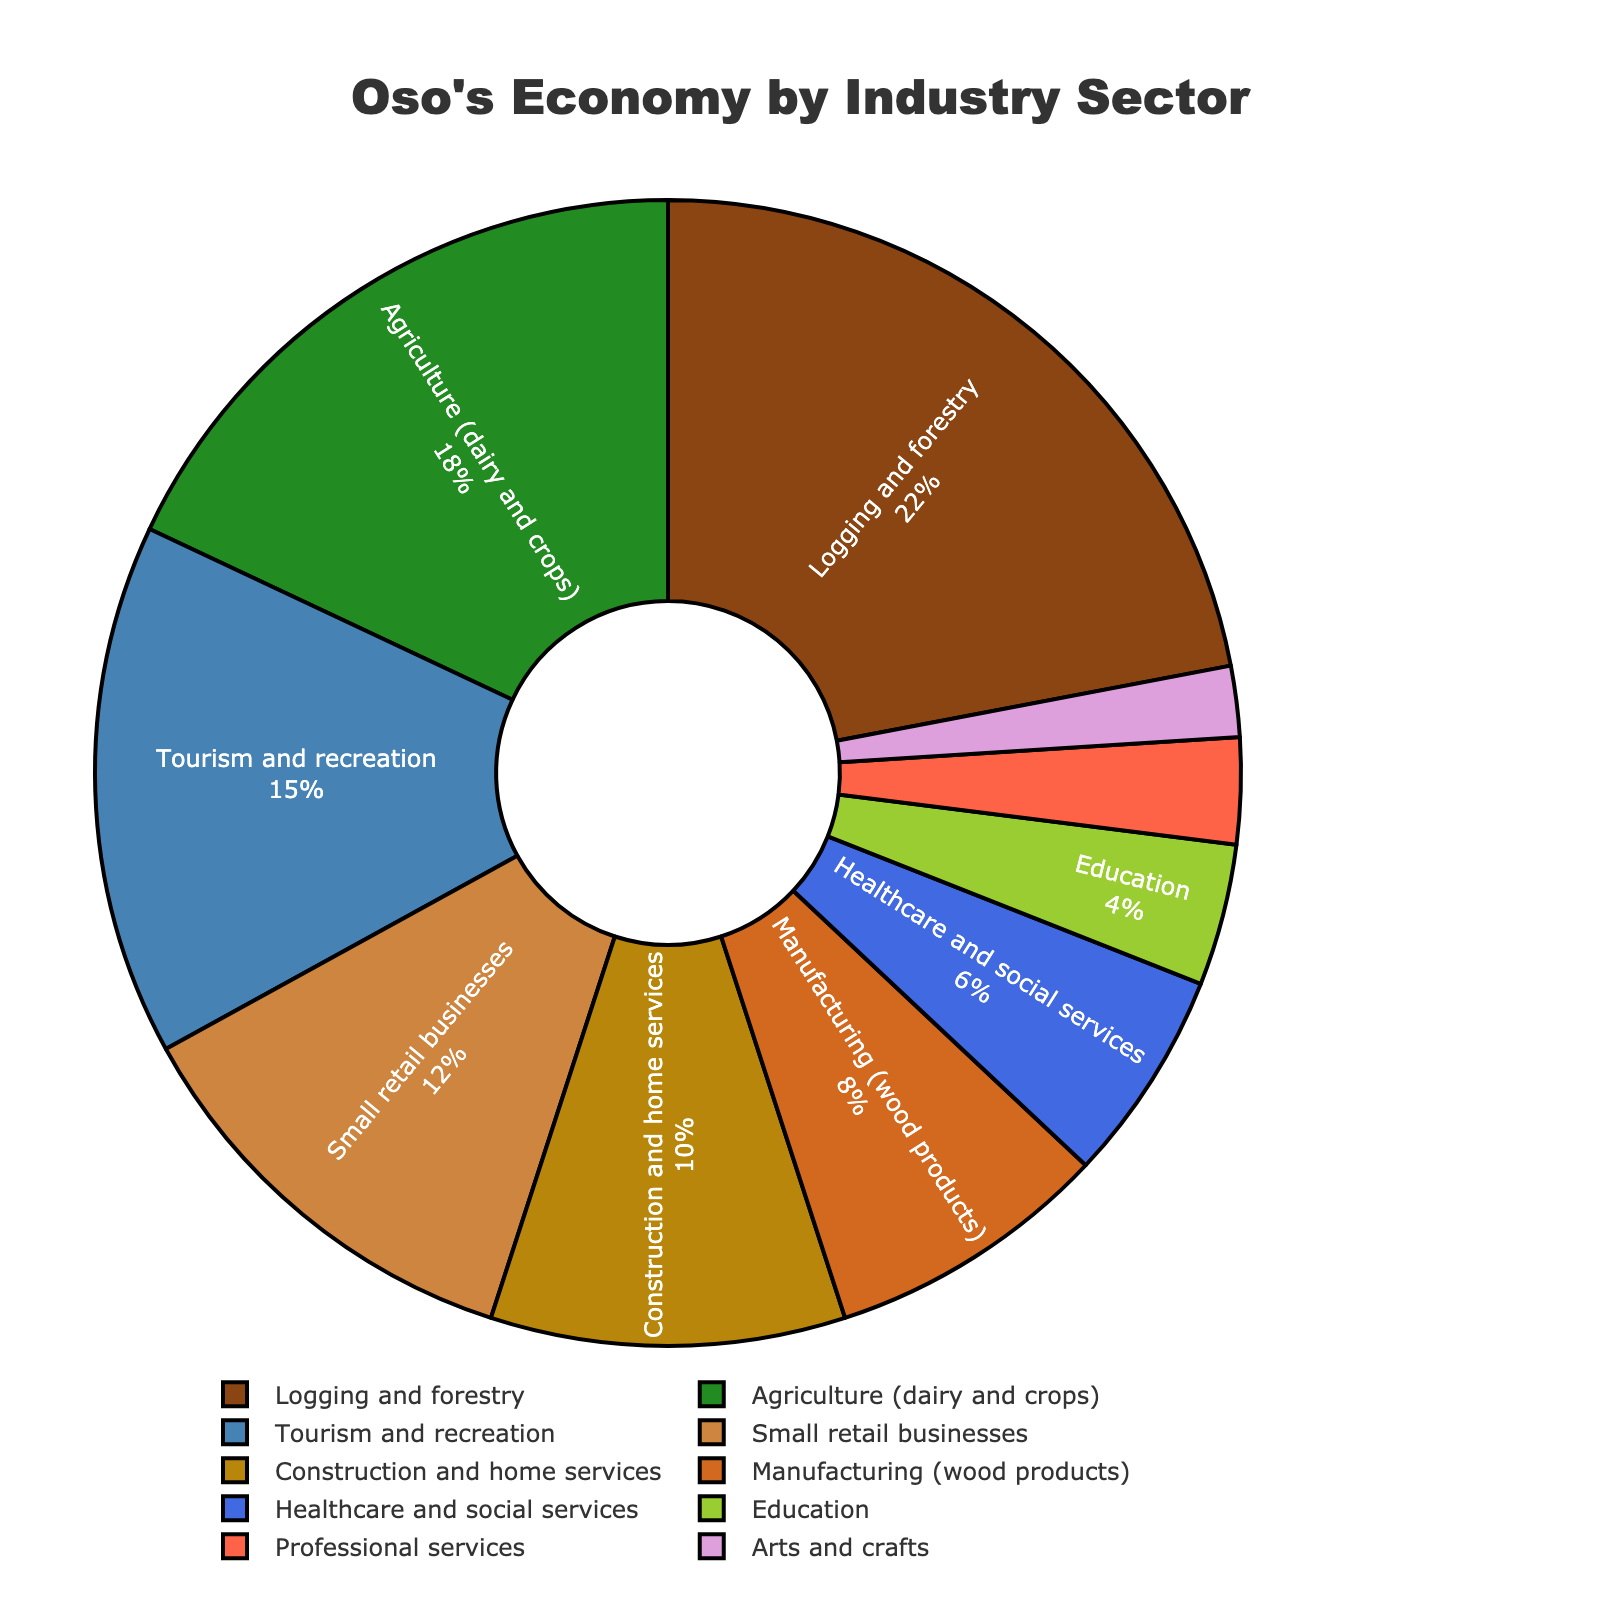What is the second-largest industry sector by percentage in Oso's economy? First, identify the largest industry sector, which is Logging and forestry with 22%. Next, look for the second largest which is Agriculture (dairy and crops) with 18%.
Answer: Agriculture (dairy and crops) What percentage of Oso's economy is attributed to healthcare and education collectively? Add the percentages of healthcare and social services (6%) and education (4%): 6% + 4% = 10%.
Answer: 10% Which industry sector contributes more to Oso's economy: Construction and home services or Manufacturing (wood products)? Compare the percentages: Construction and home services is 10%, Manufacturing (wood products) is 8%. 10% is greater than 8%.
Answer: Construction and home services If we combine the percentages of all industry sectors contributing less than 10%, what is the total? Calculate the sum of percentages for Manufacturing (wood products) (8%), Healthcare and social services (6%), Education (4%), Professional services (3%), and Arts and crafts (2%): 8% + 6% + 4% + 3% + 2% = 23%.
Answer: 23% What sector has the smallest share in Oso's economy? Identify the sector with the lowest percentage, which is Arts and crafts with 2%.
Answer: Arts and crafts How much larger is the percentage of Logging and forestry compared to Small retail businesses? Subtract the percentage of Small retail businesses (12%) from Logging and forestry (22%): 22% - 12% = 10%.
Answer: 10% Which color represents the tourism and recreation sector in the figure? The sector labeled Tourism and recreation is represented by blue.
Answer: Blue What is the combined percentage of traditional industries (Logging and forestry, Agriculture, Manufacturing) in Oso's economy? Add the percentages of Logging and forestry (22%), Agriculture (18%), and Manufacturing (8%): 22% + 18% + 8% = 48%.
Answer: 48% How does the share of Professional services compare with Education? Compare the percentages: Professional services is 3%, Education is 4%. 4% is greater than 3%.
Answer: Education What percentage more do Small retail businesses contribute compared to Arts and crafts? Subtract the percentage of Arts and crafts (2%) from Small retail businesses (12%): 12% - 2% = 10%.
Answer: 10% 